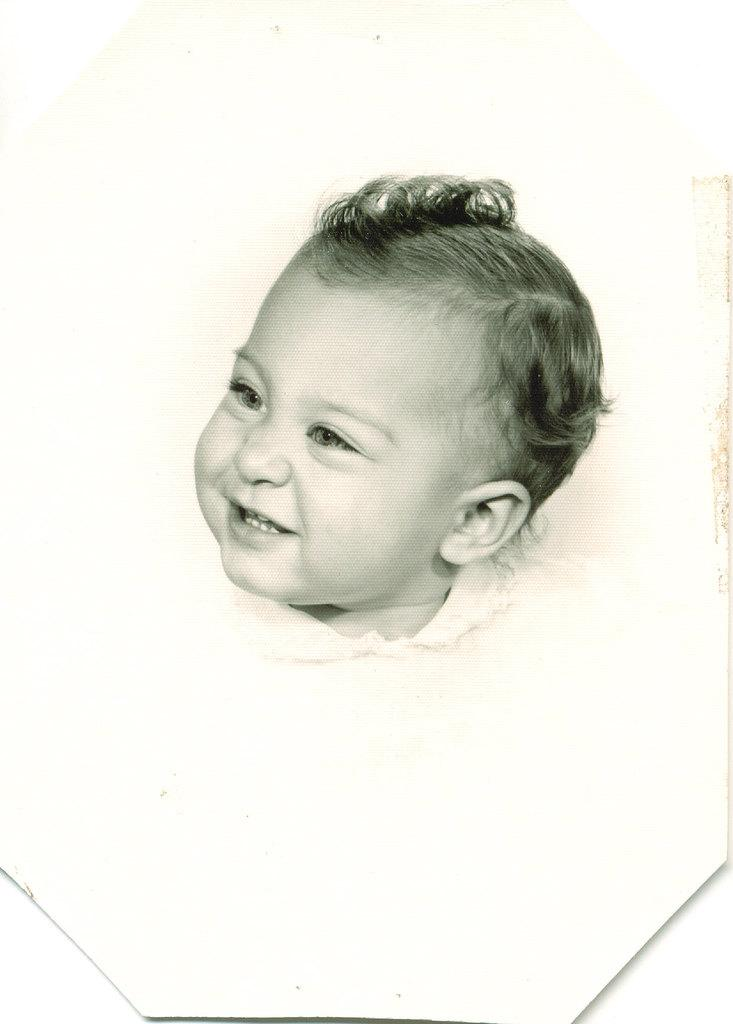What is the color scheme of the image? The image is black and white. What is the main subject of the image? There is a kid smiling in the image. How is the image presented? The image is a frame. What type of skin condition can be seen on the kid's face in the image? There is no indication of any skin condition on the kid's face in the image, as the image is black and white and does not show any details about the skin. What type of acoustics can be heard in the image? The image is a still photograph, so there are no sounds or acoustics present. --- 